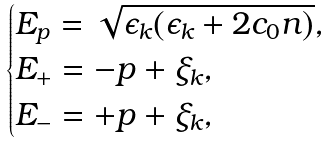Convert formula to latex. <formula><loc_0><loc_0><loc_500><loc_500>\begin{cases} E _ { p } = \sqrt { \epsilon _ { k } ( \epsilon _ { k } + 2 c _ { 0 } n ) } , \\ E _ { + } = - p + \xi _ { k } , \\ E _ { - } = + p + \xi _ { k } , \end{cases}</formula> 